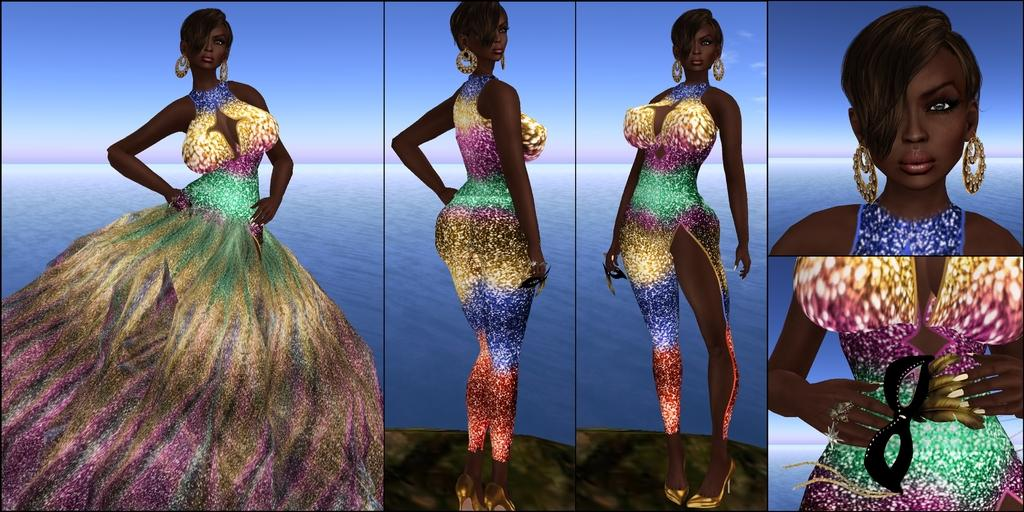What is the composition of the image? The image is a collage of multiple images. Can you describe one of the images within the collage? There is a woman in one of the images. What is the woman wearing? The woman is wearing a dress. How would you describe the dress? The dress has different colors. What can be seen in the background of the image with the woman? There is water visible behind the woman. How many rings can be seen on the calculator in the image? There is no calculator or rings present in the image. 